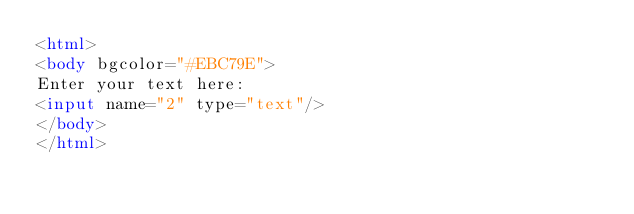Convert code to text. <code><loc_0><loc_0><loc_500><loc_500><_HTML_><html>
<body bgcolor="#EBC79E">
Enter your text here:
<input name="2" type="text"/>
</body>
</html></code> 